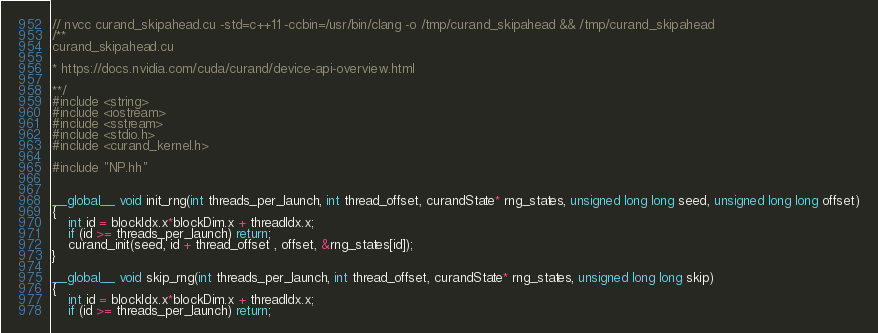<code> <loc_0><loc_0><loc_500><loc_500><_Cuda_>// nvcc curand_skipahead.cu -std=c++11 -ccbin=/usr/bin/clang -o /tmp/curand_skipahead && /tmp/curand_skipahead 
/**
curand_skipahead.cu

* https://docs.nvidia.com/cuda/curand/device-api-overview.html

**/
#include <string>
#include <iostream>
#include <sstream>
#include <stdio.h>
#include <curand_kernel.h>

#include "NP.hh"


__global__ void init_rng(int threads_per_launch, int thread_offset, curandState* rng_states, unsigned long long seed, unsigned long long offset)
{
    int id = blockIdx.x*blockDim.x + threadIdx.x;
    if (id >= threads_per_launch) return;
    curand_init(seed, id + thread_offset , offset, &rng_states[id]);  
}

__global__ void skip_rng(int threads_per_launch, int thread_offset, curandState* rng_states, unsigned long long skip)
{
    int id = blockIdx.x*blockDim.x + threadIdx.x;
    if (id >= threads_per_launch) return;</code> 